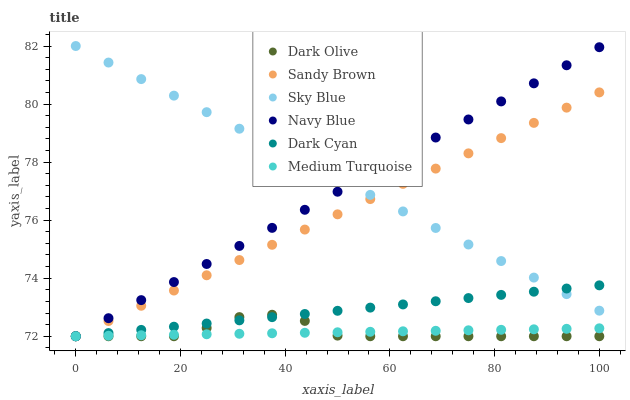Does Medium Turquoise have the minimum area under the curve?
Answer yes or no. Yes. Does Sky Blue have the maximum area under the curve?
Answer yes or no. Yes. Does Dark Olive have the minimum area under the curve?
Answer yes or no. No. Does Dark Olive have the maximum area under the curve?
Answer yes or no. No. Is Medium Turquoise the smoothest?
Answer yes or no. Yes. Is Dark Olive the roughest?
Answer yes or no. Yes. Is Dark Olive the smoothest?
Answer yes or no. No. Is Medium Turquoise the roughest?
Answer yes or no. No. Does Navy Blue have the lowest value?
Answer yes or no. Yes. Does Sky Blue have the lowest value?
Answer yes or no. No. Does Sky Blue have the highest value?
Answer yes or no. Yes. Does Dark Olive have the highest value?
Answer yes or no. No. Is Dark Olive less than Sky Blue?
Answer yes or no. Yes. Is Sky Blue greater than Medium Turquoise?
Answer yes or no. Yes. Does Medium Turquoise intersect Dark Cyan?
Answer yes or no. Yes. Is Medium Turquoise less than Dark Cyan?
Answer yes or no. No. Is Medium Turquoise greater than Dark Cyan?
Answer yes or no. No. Does Dark Olive intersect Sky Blue?
Answer yes or no. No. 